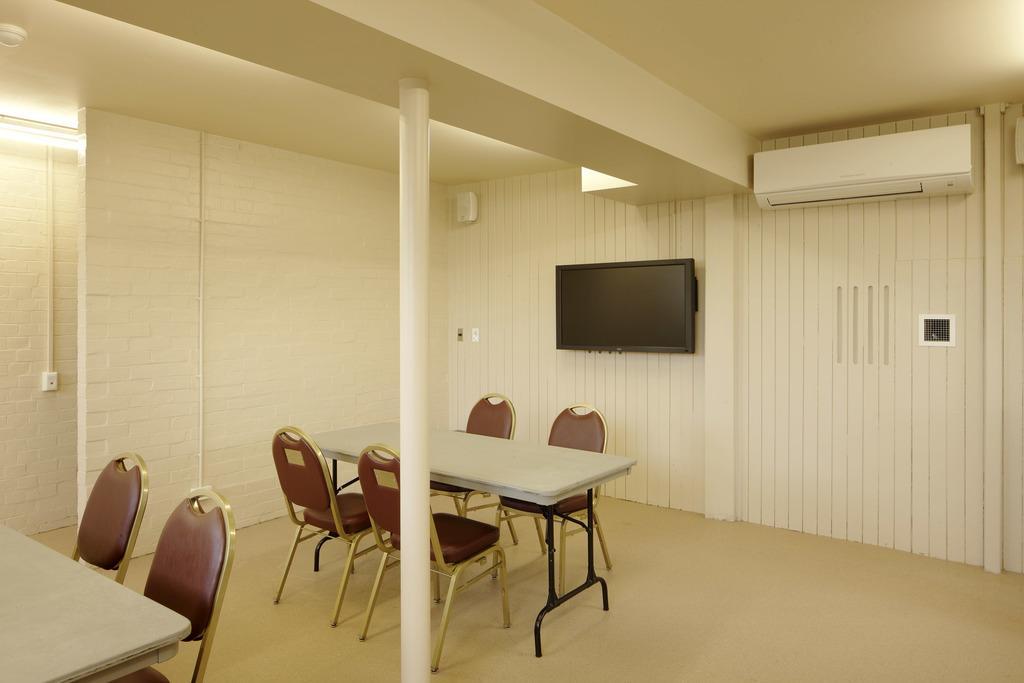Could you give a brief overview of what you see in this image? In the picture I can see the tables and chairs on the floor. There is a light on the wall on the top left side. I can see a television on the wall. There is an air conditioner on the wall on the top right side of the picture. 